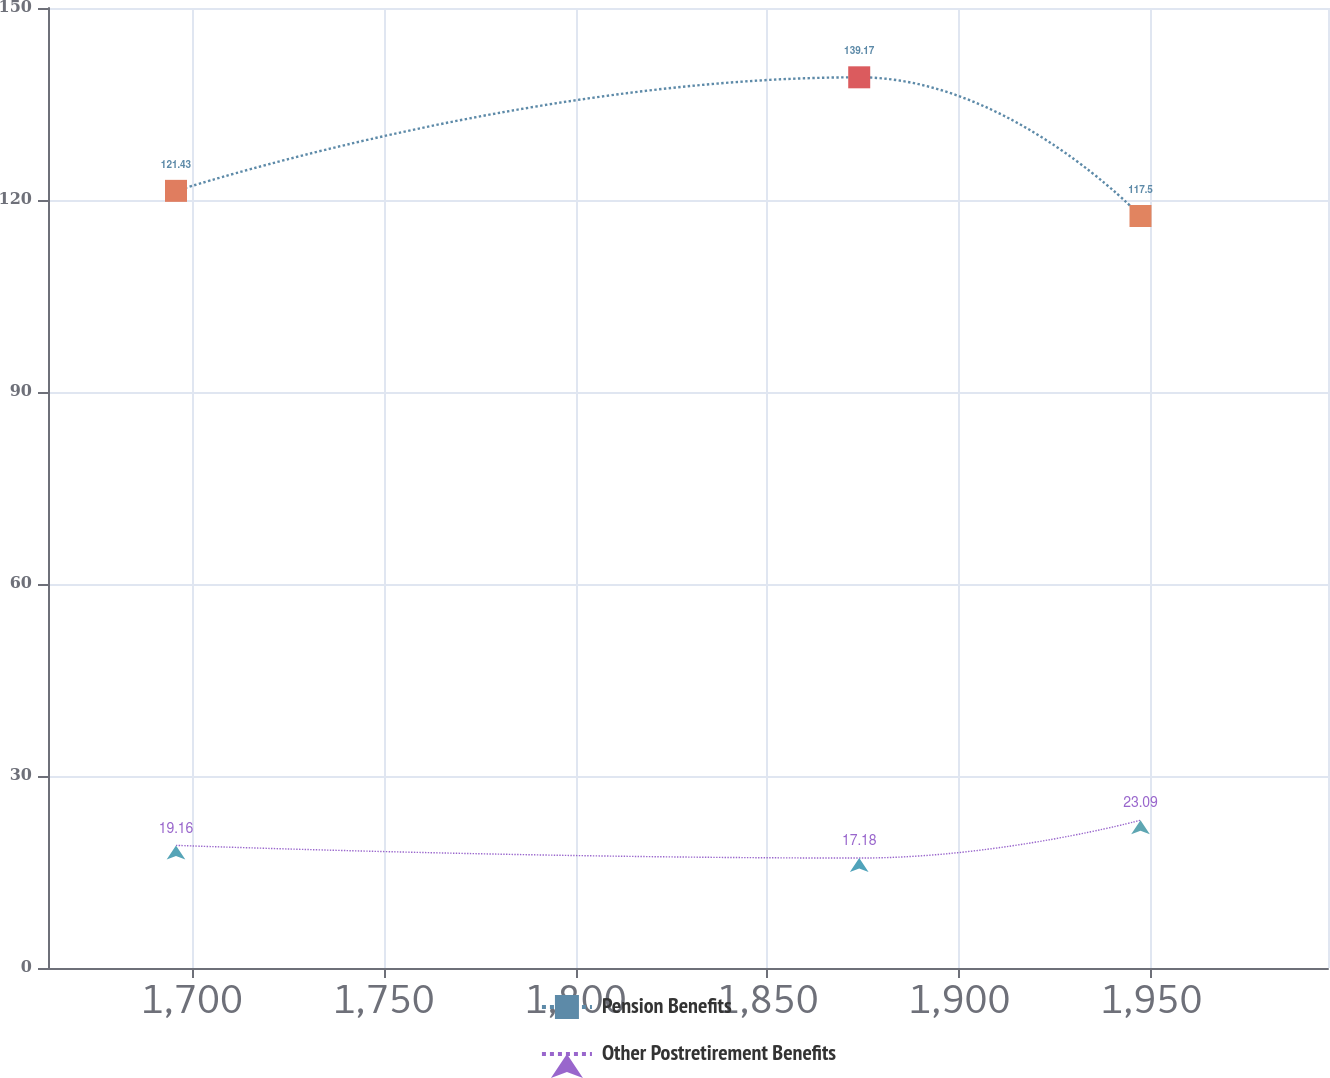Convert chart. <chart><loc_0><loc_0><loc_500><loc_500><line_chart><ecel><fcel>Pension Benefits<fcel>Other Postretirement Benefits<nl><fcel>1695.91<fcel>121.43<fcel>19.16<nl><fcel>1873.92<fcel>139.17<fcel>17.18<nl><fcel>1947.21<fcel>117.5<fcel>23.09<nl><fcel>1996.33<fcel>142.06<fcel>23.77<nl><fcel>2029.41<fcel>146.36<fcel>21.79<nl></chart> 